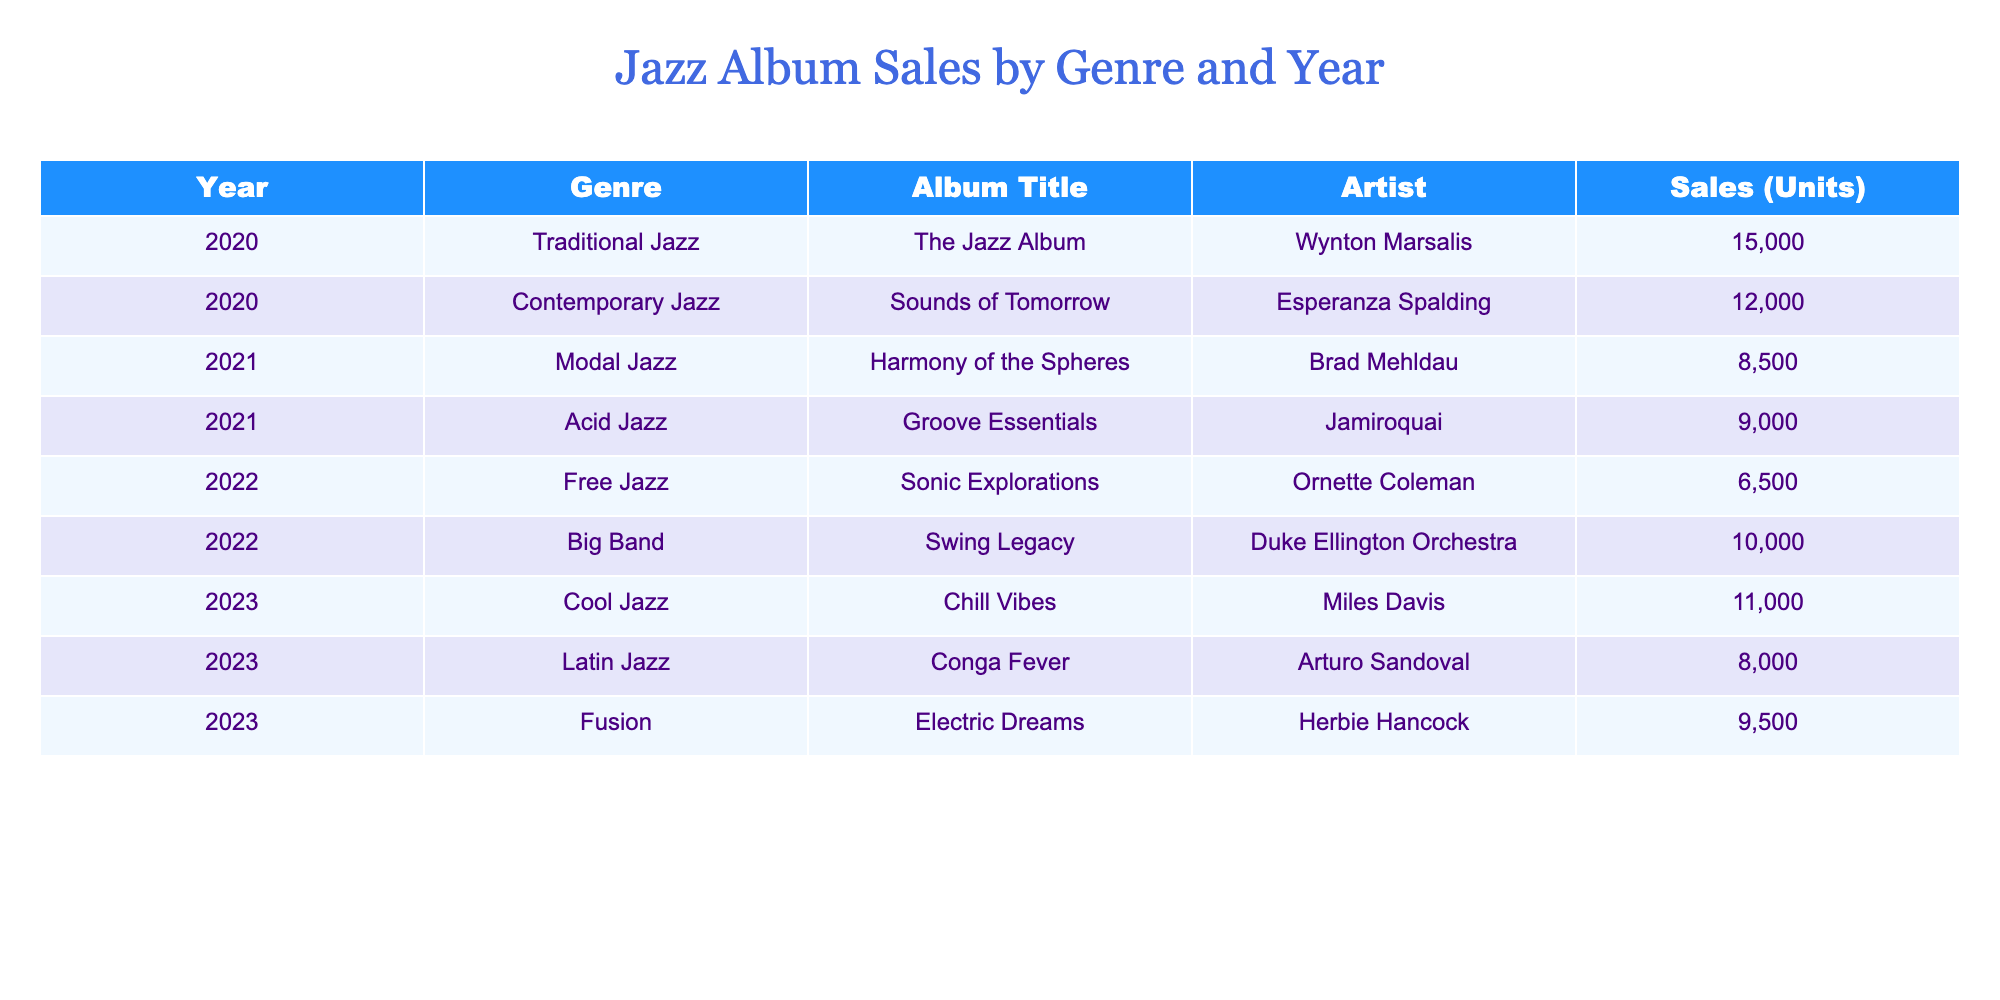What is the title of the album with the highest sales in 2020? The album with the highest sales in 2020 can be found by examining the 'Sales (Units)' column for that year. The highest sales for that year is 15000 units, associated with the album titled "The Jazz Album" by Wynton Marsalis.
Answer: The Jazz Album Which genre had the lowest album sales in 2022? Looking at the sales figures for 2022, the genre with the lowest sales is Free Jazz with 6500 units sold.
Answer: Free Jazz What is the total sales of albums released in 2023? To find the total sales for albums released in 2023, we sum the sales for each album in that year: 11000 (Cool Jazz) + 8000 (Latin Jazz) + 9500 (Fusion) = 28500 units.
Answer: 28500 Did any album from the Acid Jazz genre sell more than 9000 units? We can check the sales figure for the Acid Jazz genre specifically from the table. The sales figure for the album "Groove Essentials" is exactly 9000 units, meaning there were no albums in this genre that exceeded this sales amount.
Answer: No What was the average sales for albums in Traditional Jazz across the years? In the table, we note that there is only one album under Traditional Jazz, which is "The Jazz Album" with sales of 15000 units in 2020. Since the average is calculated by dividing the total sales by the number of albums, the average is 15000 / 1 = 15000 units.
Answer: 15000 Which artist had the highest sales for their album in 2021? In 2021, we need to compare the sales of "Harmony of the Spheres" by Brad Mehldau (8500 units) and "Groove Essentials" by Jamiroquai (9000 units). Jamiroquai had higher sales with 9000 units.
Answer: Jamiroquai How many genres have sales greater than 9000 units in 2020? In 2020, we examine the sales figures for each genre: Traditional Jazz (15000), Contemporary Jazz (12000). Both genres have sales greater than 9000 units. Therefore, there are 2 genres exceeding this figure.
Answer: 2 Is the "Electric Dreams" album classified under Big Band genre? To find this out, we look at the genre of the "Electric Dreams" album listed in the table, which is categorized under Fusion, not Big Band.
Answer: No 